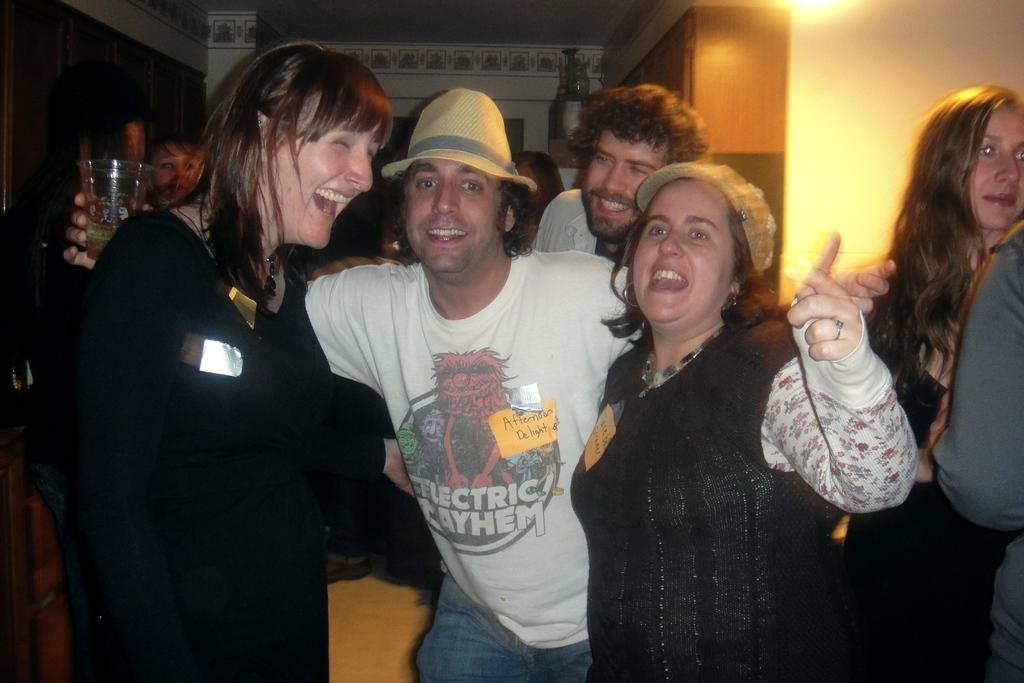How many people are in the foreground of the image? There are two women and a man in the foreground of the image. What are the individuals in the foreground doing? The individuals are standing and smiling. What can be seen in the background of the image? In the background, there are persons standing, light visible, and a wall. Can you tell me how many robins are perched on the wall in the image? There are no robins present in the image; the wall is in the background, and no birds are visible. 